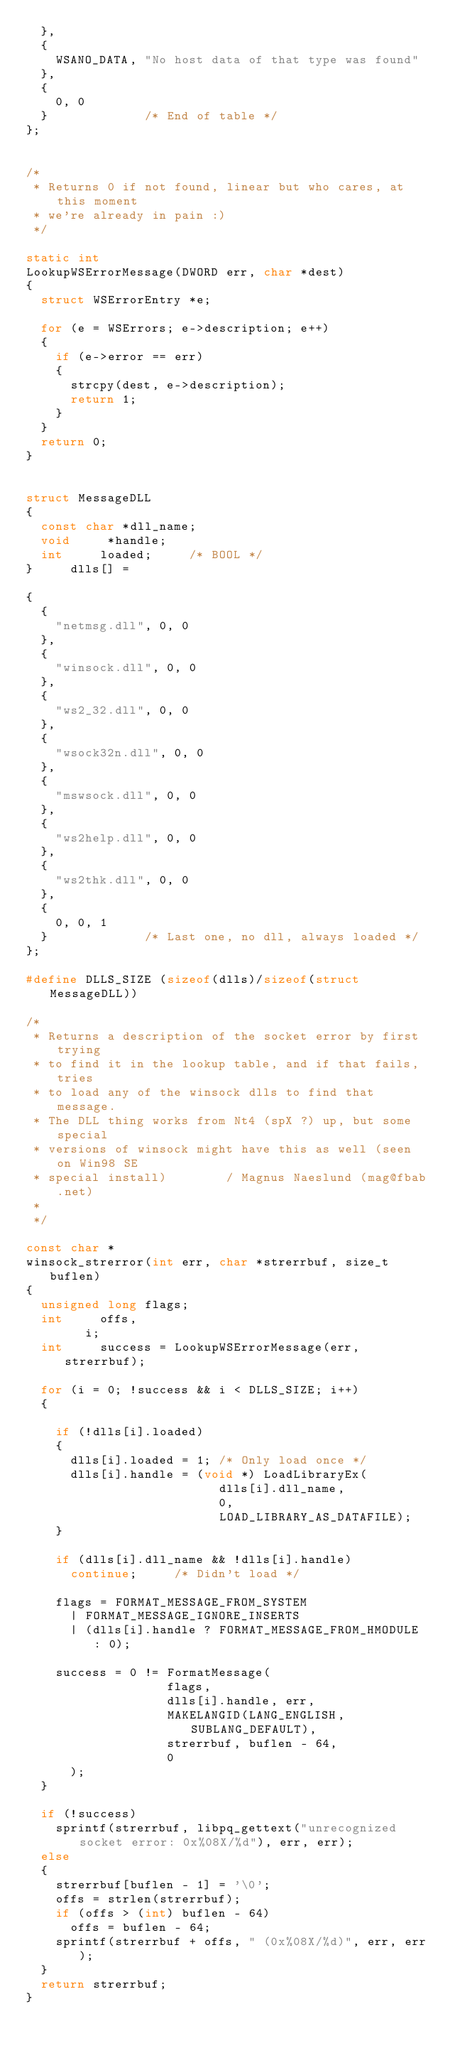<code> <loc_0><loc_0><loc_500><loc_500><_C_>	},
	{
		WSANO_DATA, "No host data of that type was found"
	},
	{
		0, 0
	}							/* End of table */
};


/*
 * Returns 0 if not found, linear but who cares, at this moment
 * we're already in pain :)
 */

static int
LookupWSErrorMessage(DWORD err, char *dest)
{
	struct WSErrorEntry *e;

	for (e = WSErrors; e->description; e++)
	{
		if (e->error == err)
		{
			strcpy(dest, e->description);
			return 1;
		}
	}
	return 0;
}


struct MessageDLL
{
	const char *dll_name;
	void	   *handle;
	int			loaded;			/* BOOL */
}			dlls[] =

{
	{
		"netmsg.dll", 0, 0
	},
	{
		"winsock.dll", 0, 0
	},
	{
		"ws2_32.dll", 0, 0
	},
	{
		"wsock32n.dll", 0, 0
	},
	{
		"mswsock.dll", 0, 0
	},
	{
		"ws2help.dll", 0, 0
	},
	{
		"ws2thk.dll", 0, 0
	},
	{
		0, 0, 1
	}							/* Last one, no dll, always loaded */
};

#define DLLS_SIZE (sizeof(dlls)/sizeof(struct MessageDLL))

/*
 * Returns a description of the socket error by first trying
 * to find it in the lookup table, and if that fails, tries
 * to load any of the winsock dlls to find that message.
 * The DLL thing works from Nt4 (spX ?) up, but some special
 * versions of winsock might have this as well (seen on Win98 SE
 * special install)			   / Magnus Naeslund (mag@fbab.net)
 *
 */

const char *
winsock_strerror(int err, char *strerrbuf, size_t buflen)
{
	unsigned long flags;
	int			offs,
				i;
	int			success = LookupWSErrorMessage(err, strerrbuf);

	for (i = 0; !success && i < DLLS_SIZE; i++)
	{

		if (!dlls[i].loaded)
		{
			dlls[i].loaded = 1; /* Only load once */
			dlls[i].handle = (void *) LoadLibraryEx(
													dlls[i].dll_name,
													0,
													LOAD_LIBRARY_AS_DATAFILE);
		}

		if (dlls[i].dll_name && !dlls[i].handle)
			continue;			/* Didn't load */

		flags = FORMAT_MESSAGE_FROM_SYSTEM
			| FORMAT_MESSAGE_IGNORE_INSERTS
			| (dlls[i].handle ? FORMAT_MESSAGE_FROM_HMODULE : 0);

		success = 0 != FormatMessage(
									 flags,
									 dlls[i].handle, err,
									 MAKELANGID(LANG_ENGLISH, SUBLANG_DEFAULT),
									 strerrbuf, buflen - 64,
									 0
			);
	}

	if (!success)
		sprintf(strerrbuf, libpq_gettext("unrecognized socket error: 0x%08X/%d"), err, err);
	else
	{
		strerrbuf[buflen - 1] = '\0';
		offs = strlen(strerrbuf);
		if (offs > (int) buflen - 64)
			offs = buflen - 64;
		sprintf(strerrbuf + offs, " (0x%08X/%d)", err, err);
	}
	return strerrbuf;
}
</code> 